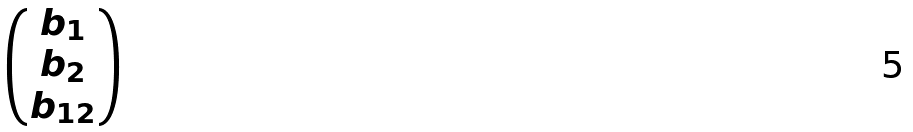Convert formula to latex. <formula><loc_0><loc_0><loc_500><loc_500>\begin{pmatrix} b _ { 1 } \\ b _ { 2 } \\ b _ { 1 2 } \end{pmatrix}</formula> 